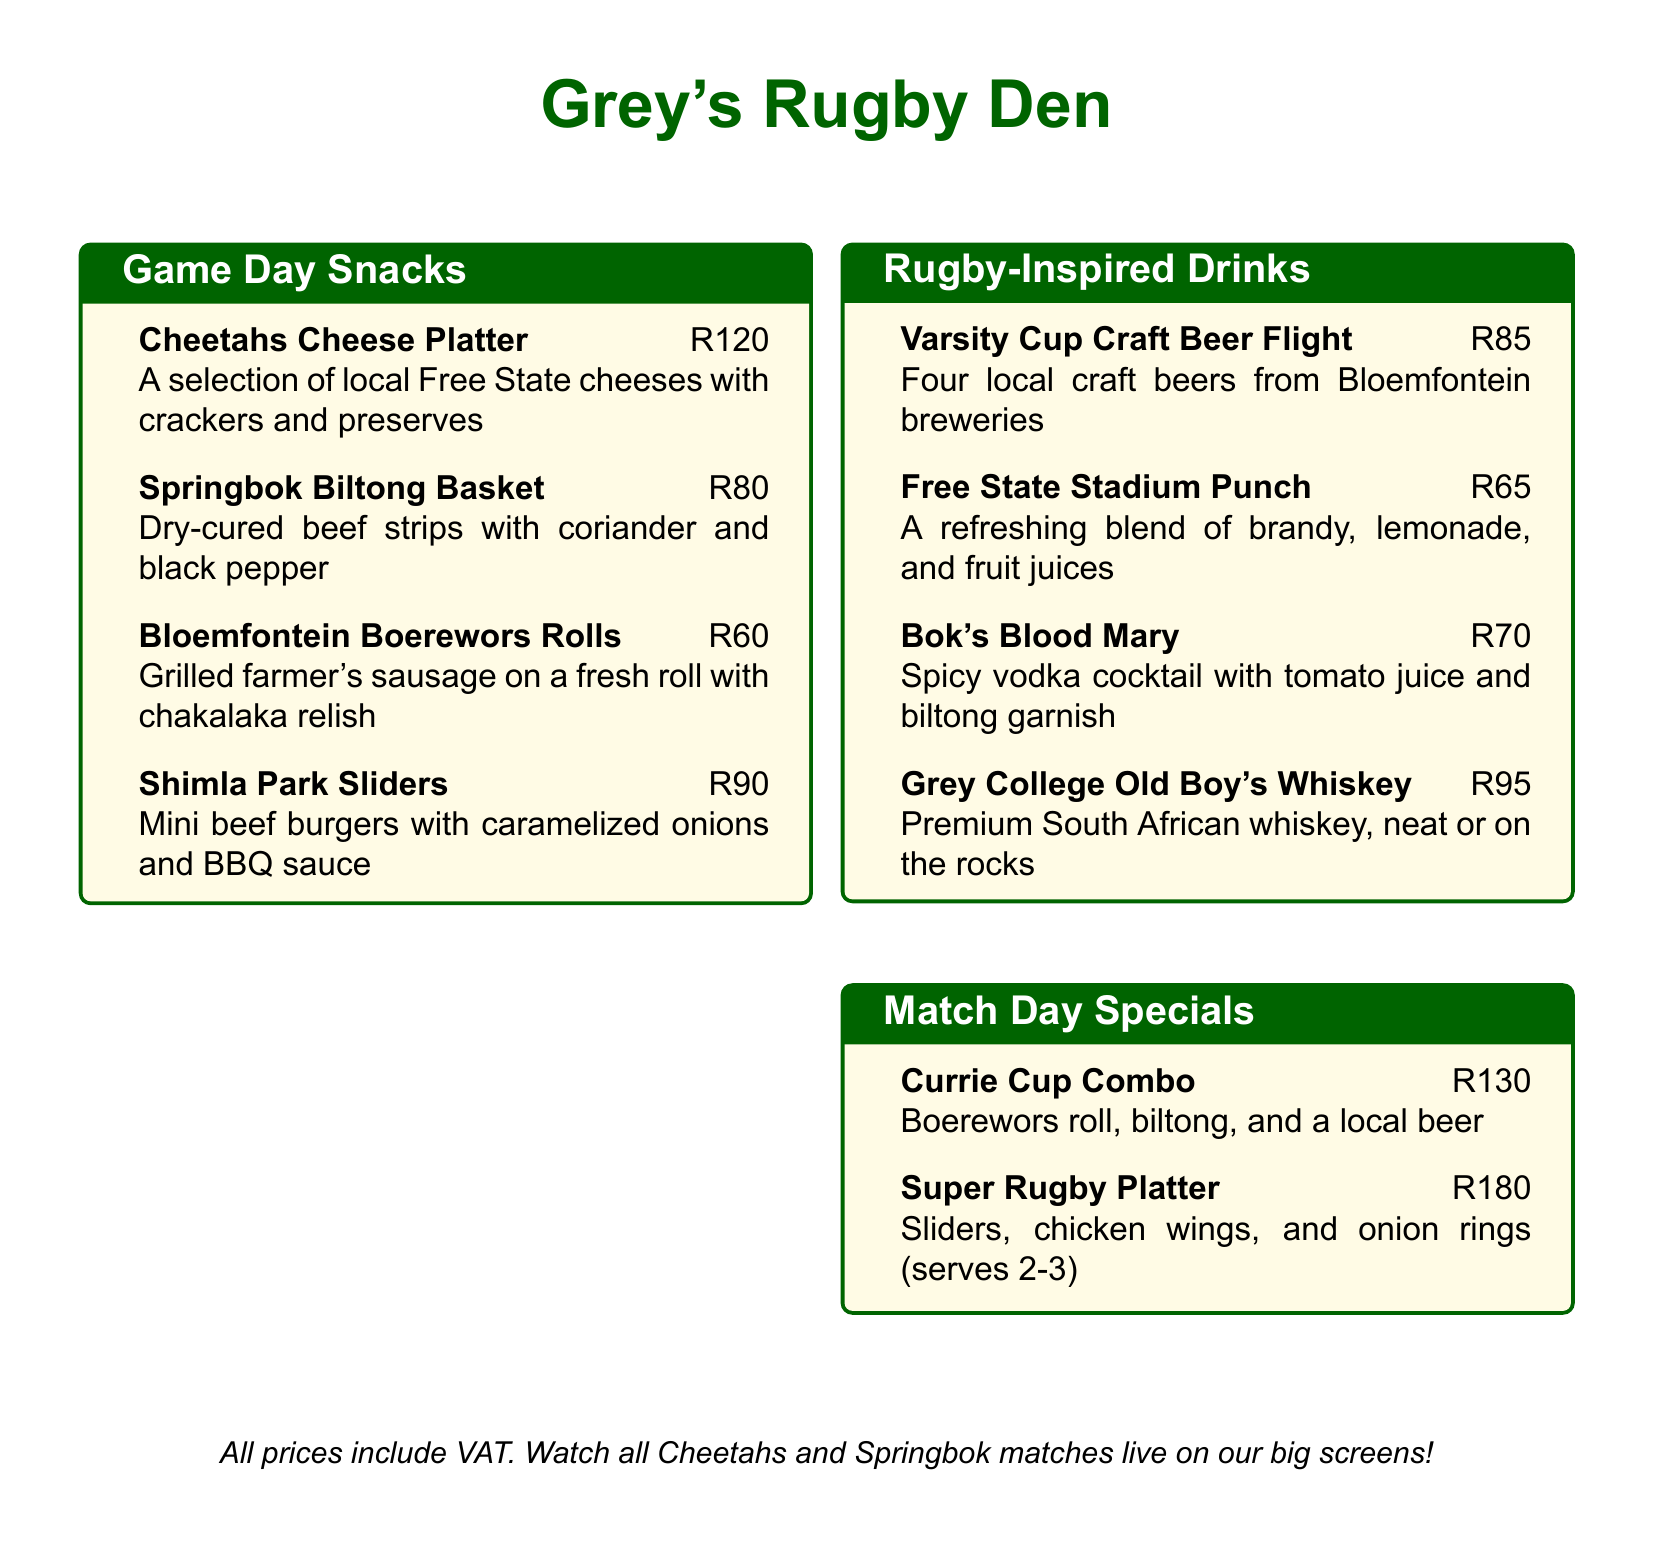What is the name of the craft beer flight? The name of the craft beer flight is listed under the drinks section of the menu.
Answer: Varsity Cup Craft Beer Flight How much do the Shimla Park Sliders cost? The cost of the Shimla Park Sliders is indicated next to the item in the game day snacks section.
Answer: R90 What is included in the Currie Cup Combo? The Currie Cup Combo is described with the items included in it at the bottom of the snacks section.
Answer: Boerewors roll, biltong, and a local beer How many local craft beers are in the flight? The number of local craft beers in the flight is directly stated in the drinks description.
Answer: Four What is the price of the Super Rugby Platter? The price of the Super Rugby Platter is listed in the match day specials section of the menu.
Answer: R180 Which drink has a biltong garnish? The drink with a biltong garnish is specified in its description in the drinks section.
Answer: Bok's Blood Mary What kind of sausage is in the Bloemfontein Boerewors Rolls? The type of sausage can be found in the description of the Bloemfontein Boerewors Rolls in the game day snacks section.
Answer: Farmer's sausage What does the Free State Stadium Punch contain? The ingredients of the Free State Stadium Punch are detailed in its drink description.
Answer: Brandy, lemonade, and fruit juices 